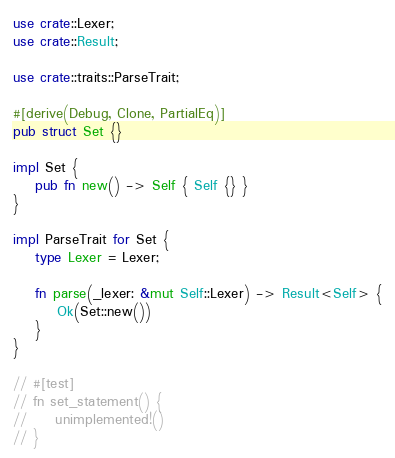<code> <loc_0><loc_0><loc_500><loc_500><_Rust_>use crate::Lexer;
use crate::Result;

use crate::traits::ParseTrait;

#[derive(Debug, Clone, PartialEq)]
pub struct Set {}

impl Set {
    pub fn new() -> Self { Self {} }
}

impl ParseTrait for Set {
    type Lexer = Lexer;

    fn parse(_lexer: &mut Self::Lexer) -> Result<Self> {
        Ok(Set::new())
    }
}

// #[test]
// fn set_statement() {
//     unimplemented!()
// }
</code> 